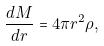<formula> <loc_0><loc_0><loc_500><loc_500>\frac { d M } { d r } = 4 \pi r ^ { 2 } \rho ,</formula> 